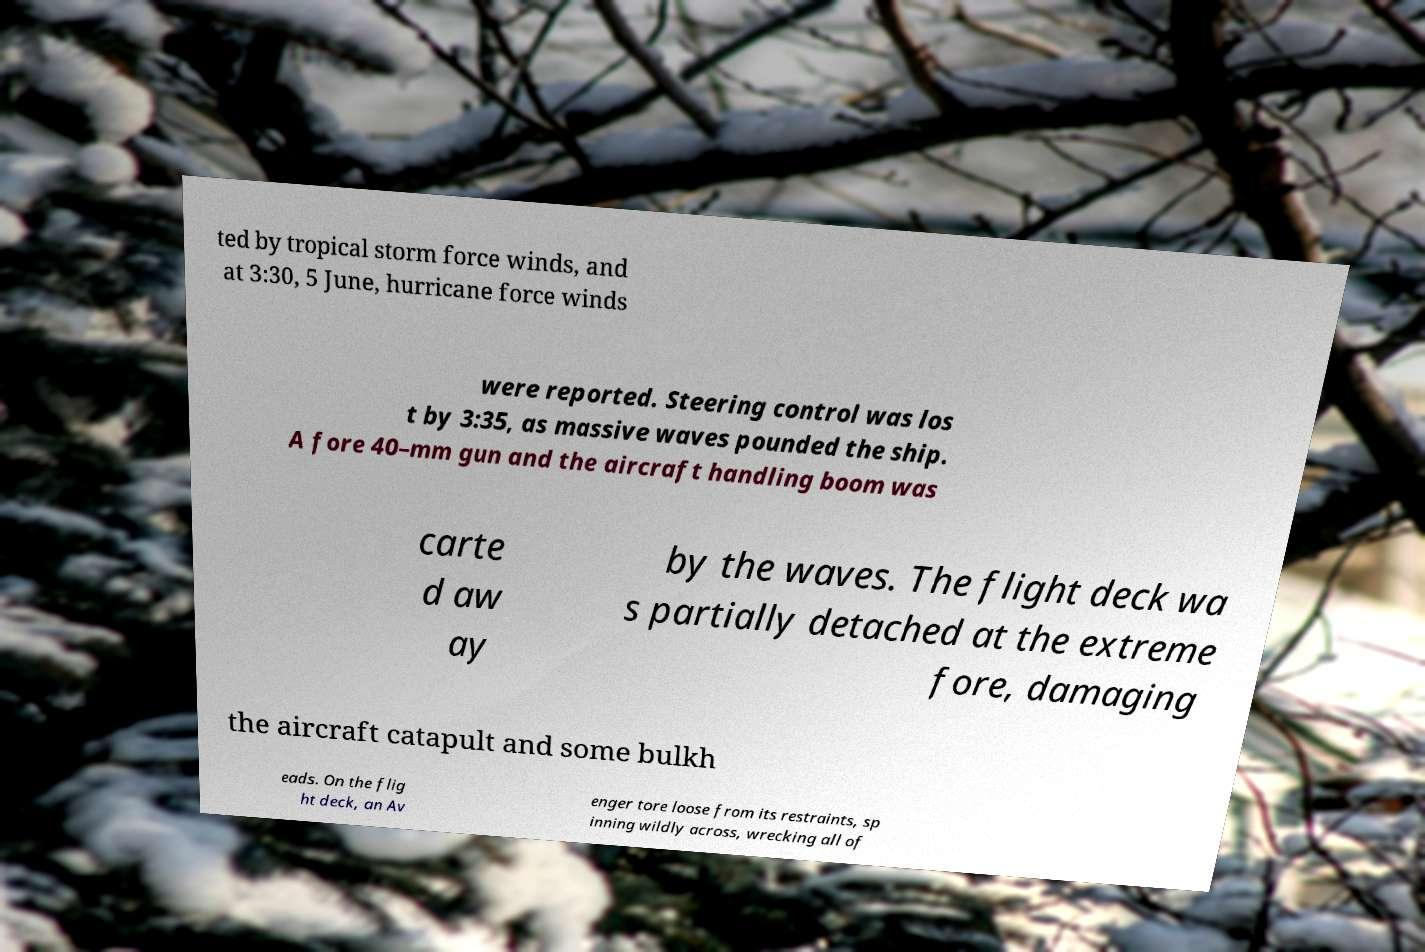Please identify and transcribe the text found in this image. ted by tropical storm force winds, and at 3:30, 5 June, hurricane force winds were reported. Steering control was los t by 3:35, as massive waves pounded the ship. A fore 40–mm gun and the aircraft handling boom was carte d aw ay by the waves. The flight deck wa s partially detached at the extreme fore, damaging the aircraft catapult and some bulkh eads. On the flig ht deck, an Av enger tore loose from its restraints, sp inning wildly across, wrecking all of 